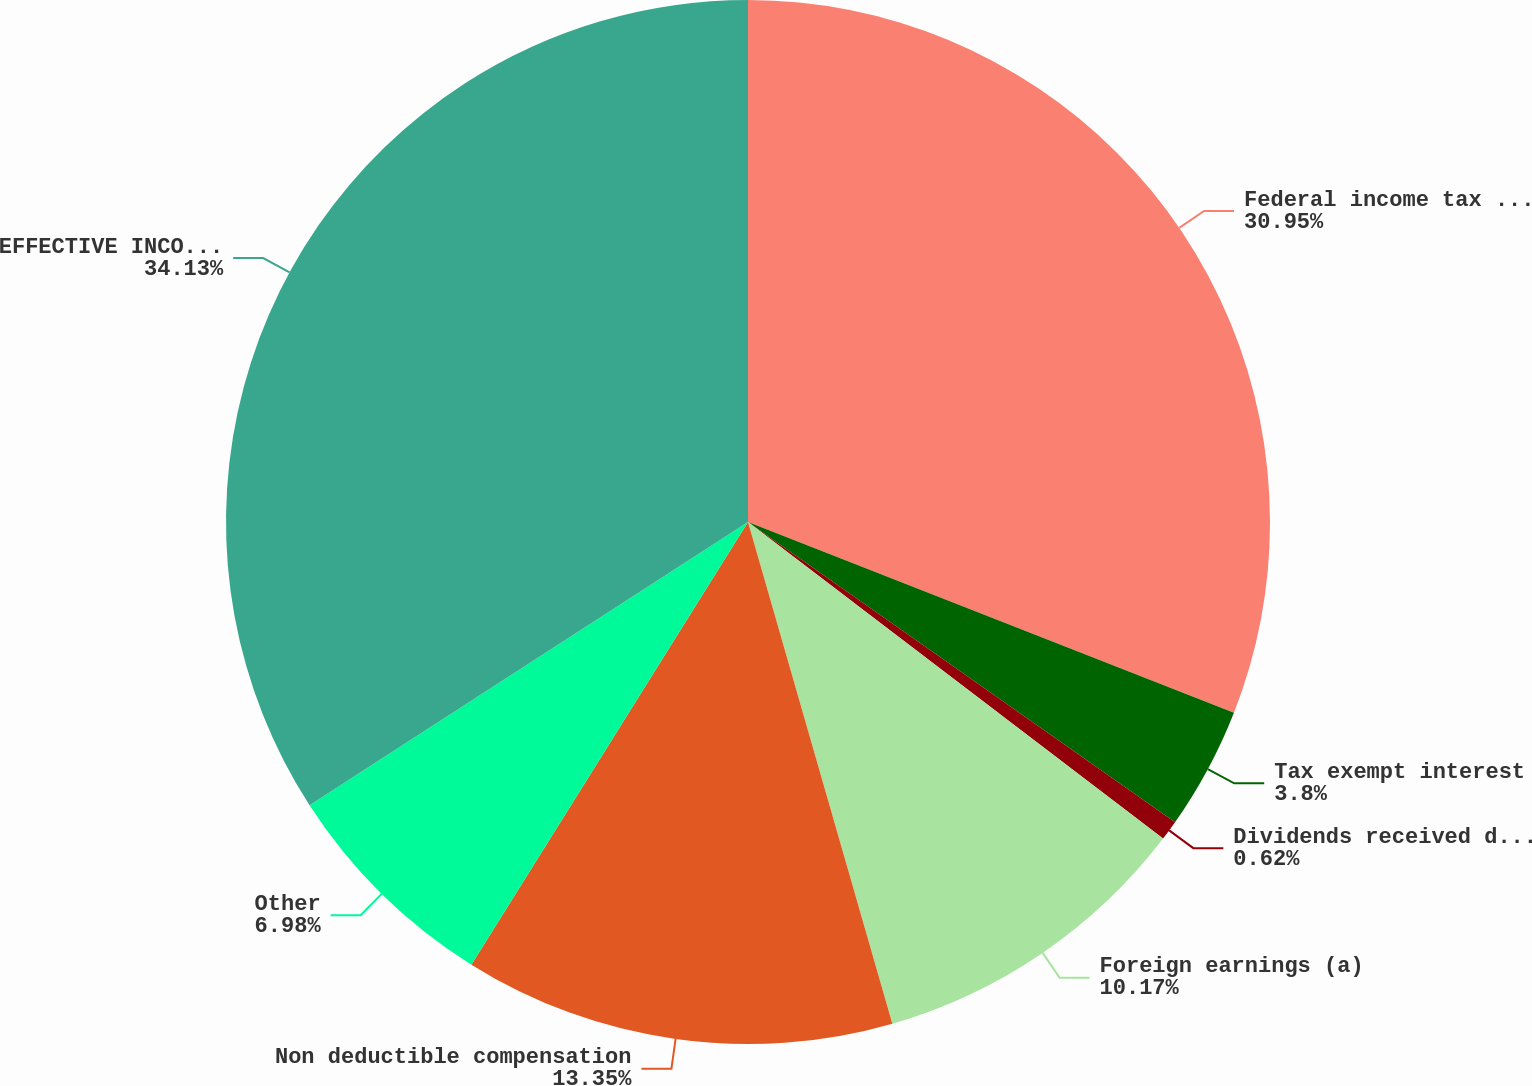<chart> <loc_0><loc_0><loc_500><loc_500><pie_chart><fcel>Federal income tax rate<fcel>Tax exempt interest<fcel>Dividends received deduction<fcel>Foreign earnings (a)<fcel>Non deductible compensation<fcel>Other<fcel>EFFECTIVE INCOME TAX RATE<nl><fcel>30.95%<fcel>3.8%<fcel>0.62%<fcel>10.17%<fcel>13.35%<fcel>6.98%<fcel>34.13%<nl></chart> 